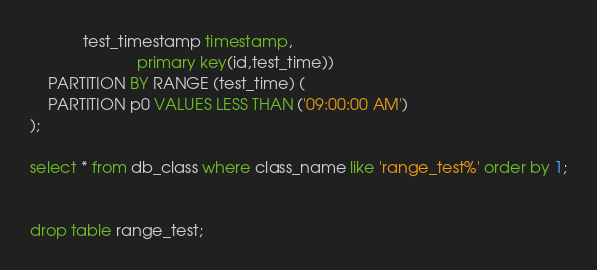<code> <loc_0><loc_0><loc_500><loc_500><_SQL_>			test_timestamp timestamp,
                        primary key(id,test_time))
	PARTITION BY RANGE (test_time) (
	PARTITION p0 VALUES LESS THAN ('09:00:00 AM')
);

select * from db_class where class_name like 'range_test%' order by 1;


drop table range_test;
</code> 